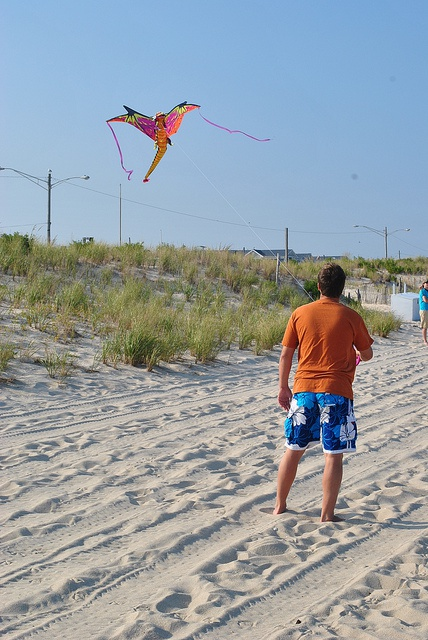Describe the objects in this image and their specific colors. I can see people in lightblue, maroon, darkgray, black, and brown tones, kite in lightblue, red, and purple tones, and people in lightblue, gray, teal, and tan tones in this image. 